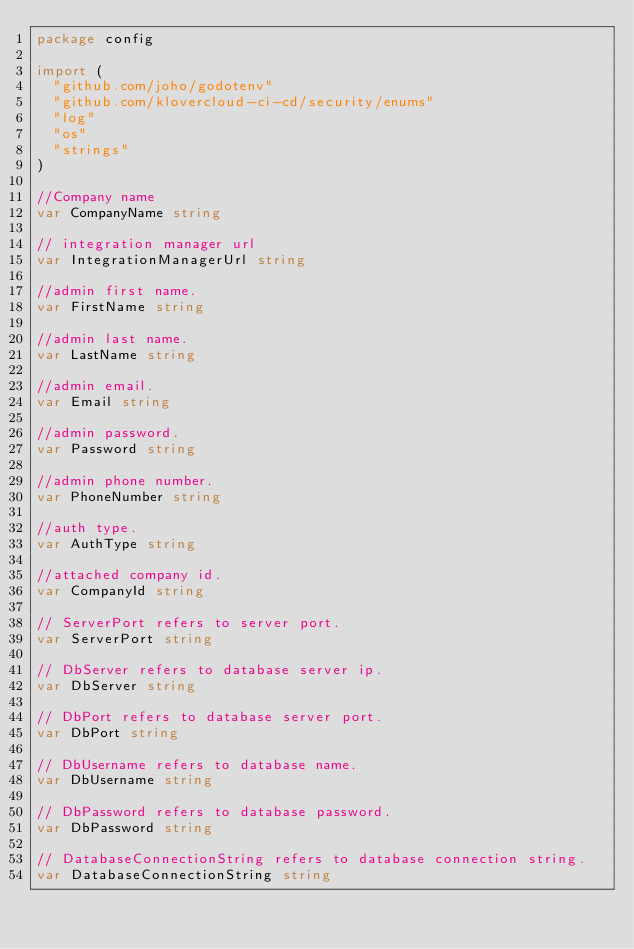Convert code to text. <code><loc_0><loc_0><loc_500><loc_500><_Go_>package config

import (
	"github.com/joho/godotenv"
	"github.com/klovercloud-ci-cd/security/enums"
	"log"
	"os"
	"strings"
)

//Company name
var CompanyName string

// integration manager url
var IntegrationManagerUrl string

//admin first name.
var FirstName string

//admin last name.
var LastName string

//admin email.
var Email string

//admin password.
var Password string

//admin phone number.
var PhoneNumber string

//auth type.
var AuthType string

//attached company id.
var CompanyId string

// ServerPort refers to server port.
var ServerPort string

// DbServer refers to database server ip.
var DbServer string

// DbPort refers to database server port.
var DbPort string

// DbUsername refers to database name.
var DbUsername string

// DbPassword refers to database password.
var DbPassword string

// DatabaseConnectionString refers to database connection string.
var DatabaseConnectionString string
</code> 